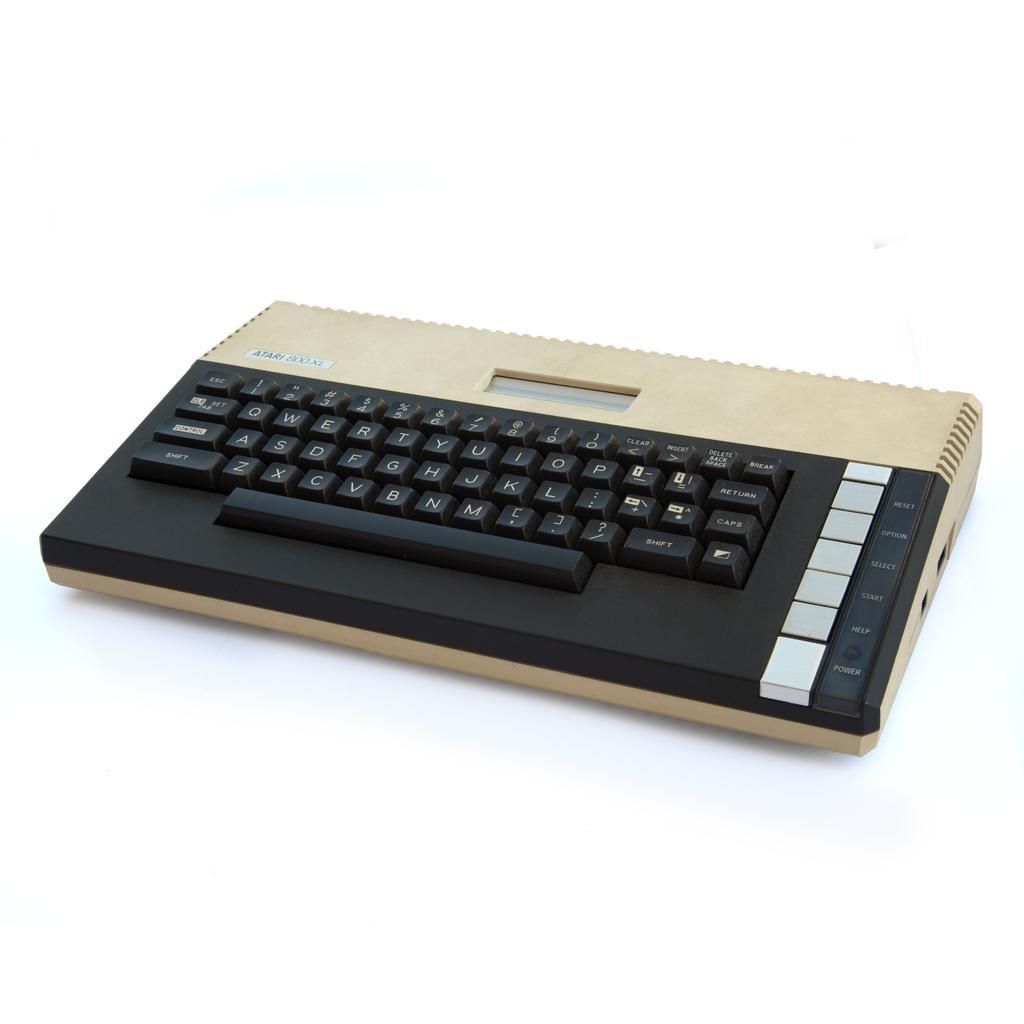<image>
Present a compact description of the photo's key features. black and gold atari 800xl computer against a white background 